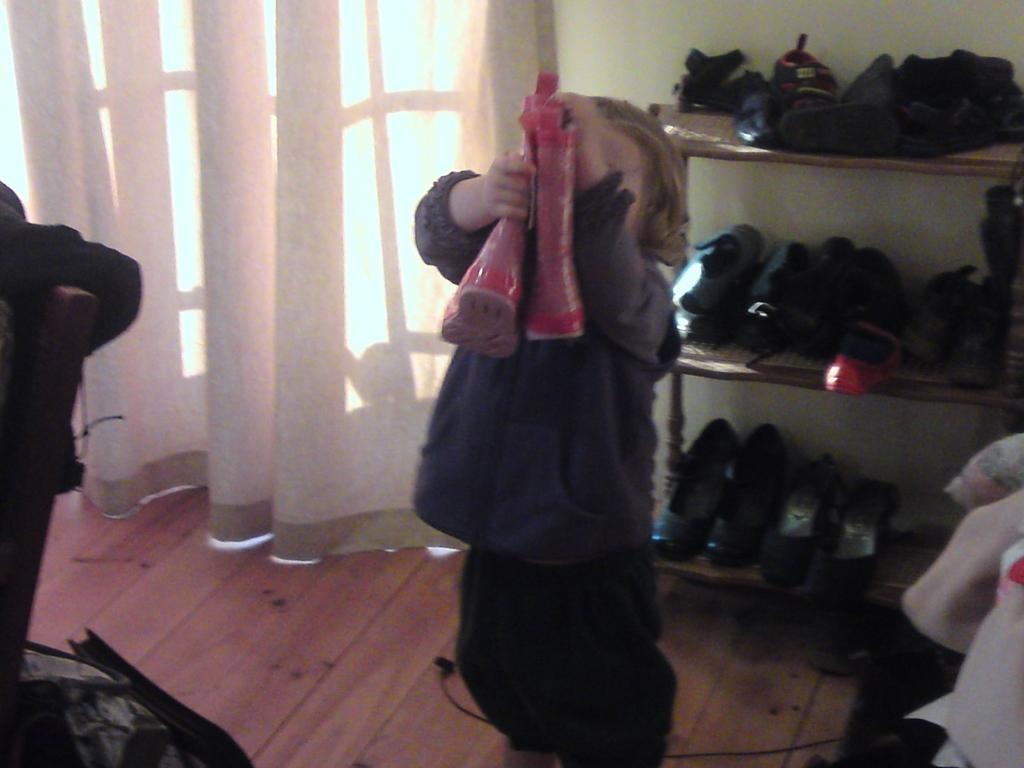What is the person holding in the image? The person is holding pink color shoes in the image. What can be seen in the background of the image? There is a window, a white color curtain, and a wall visible in the background of the image. What is on the floor in the image? There are objects on the floor in the image. Where are the shoes in the image? Besides the person holding them, there are also shoes in a rack in the image. What type of lace is used to decorate the volcano in the image? There is no volcano present in the image, and therefore no lace can be used to decorate it. 